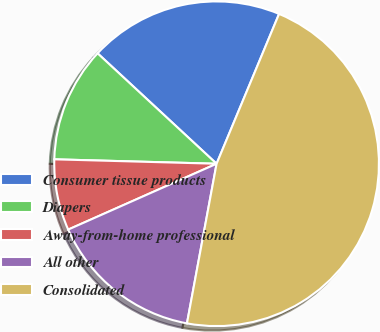<chart> <loc_0><loc_0><loc_500><loc_500><pie_chart><fcel>Consumer tissue products<fcel>Diapers<fcel>Away-from-home professional<fcel>All other<fcel>Consolidated<nl><fcel>19.38%<fcel>11.47%<fcel>7.08%<fcel>15.43%<fcel>46.63%<nl></chart> 